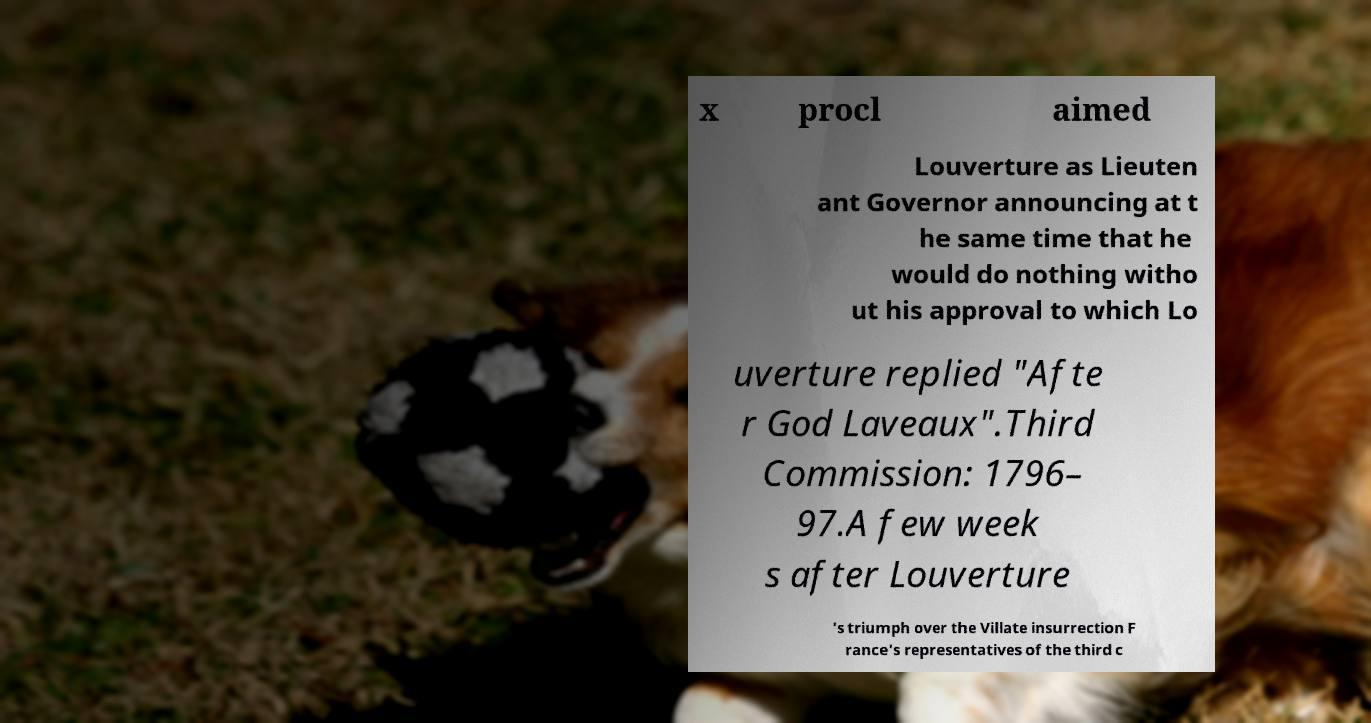Please read and relay the text visible in this image. What does it say? x procl aimed Louverture as Lieuten ant Governor announcing at t he same time that he would do nothing witho ut his approval to which Lo uverture replied "Afte r God Laveaux".Third Commission: 1796– 97.A few week s after Louverture 's triumph over the Villate insurrection F rance's representatives of the third c 